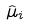<formula> <loc_0><loc_0><loc_500><loc_500>\hat { \mu } _ { i }</formula> 